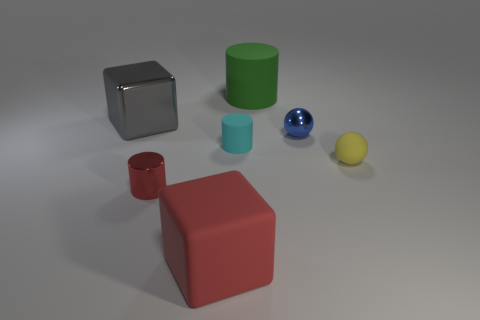Add 1 red rubber blocks. How many objects exist? 8 Subtract all cylinders. How many objects are left? 4 Add 6 red things. How many red things are left? 8 Add 7 gray cubes. How many gray cubes exist? 8 Subtract 0 cyan cubes. How many objects are left? 7 Subtract all small blue balls. Subtract all red objects. How many objects are left? 4 